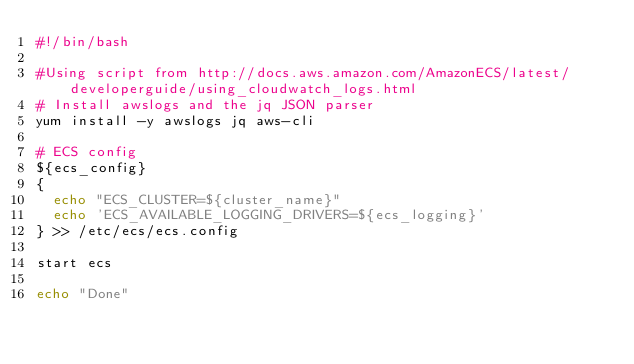<code> <loc_0><loc_0><loc_500><loc_500><_Bash_>#!/bin/bash

#Using script from http://docs.aws.amazon.com/AmazonECS/latest/developerguide/using_cloudwatch_logs.html
# Install awslogs and the jq JSON parser
yum install -y awslogs jq aws-cli

# ECS config
${ecs_config}
{
  echo "ECS_CLUSTER=${cluster_name}"
  echo 'ECS_AVAILABLE_LOGGING_DRIVERS=${ecs_logging}'
} >> /etc/ecs/ecs.config

start ecs

echo "Done"
</code> 